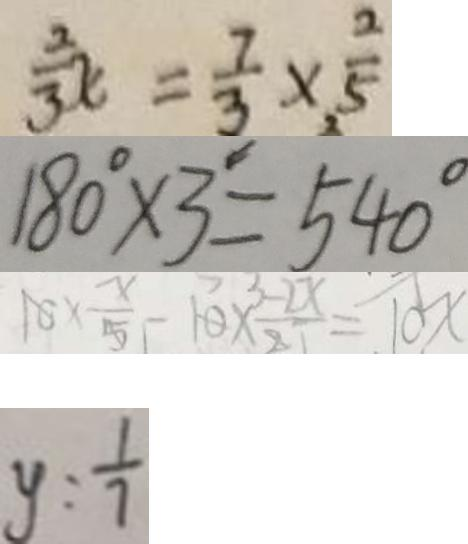<formula> <loc_0><loc_0><loc_500><loc_500>\frac { 3 } { 3 } x = \frac { 7 } { 3 } \times \frac { 2 } { 5 } 
 1 8 0 ^ { \circ } \times 3 ^ { \prime } = 5 4 0 ^ { \circ } 
 1 0 \times \frac { x } { 5 } - 1 0 \times \frac { - 2 x } { 2 7 } = 1 0 x 
 y = \frac { 1 } { 7 }</formula> 